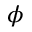<formula> <loc_0><loc_0><loc_500><loc_500>\phi</formula> 